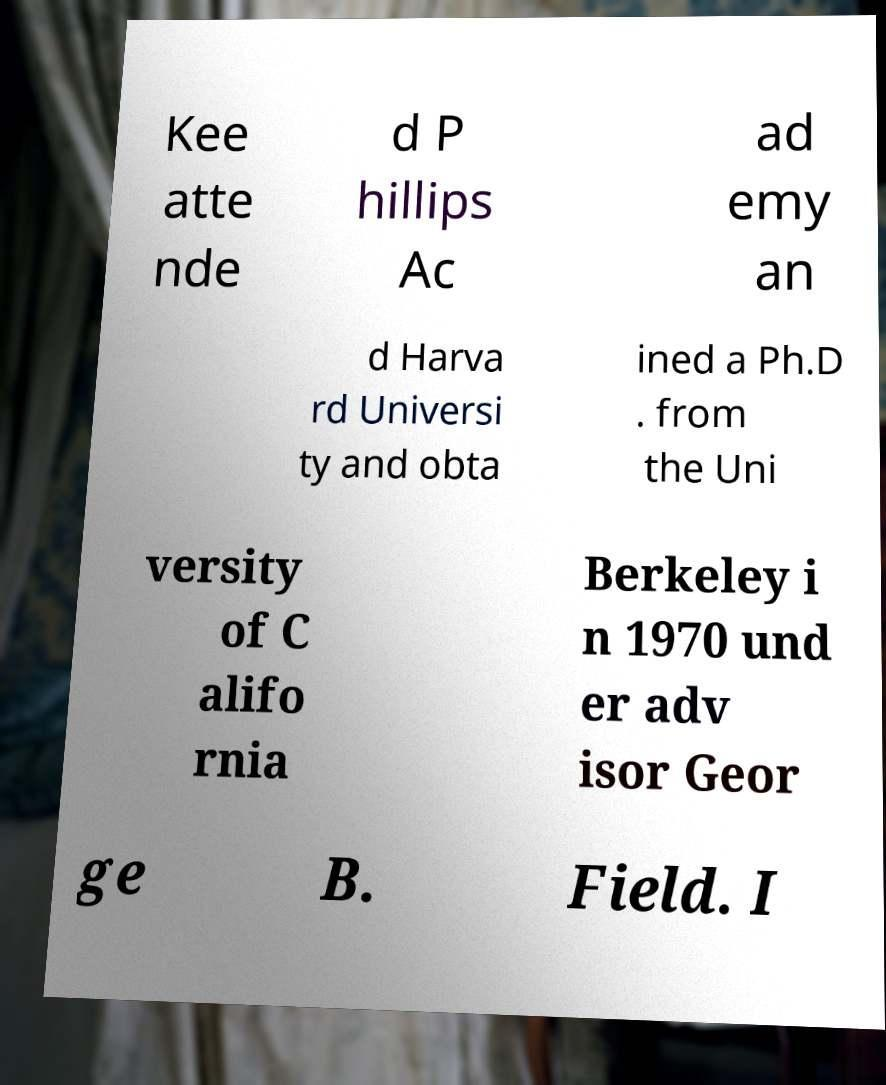I need the written content from this picture converted into text. Can you do that? Kee atte nde d P hillips Ac ad emy an d Harva rd Universi ty and obta ined a Ph.D . from the Uni versity of C alifo rnia Berkeley i n 1970 und er adv isor Geor ge B. Field. I 